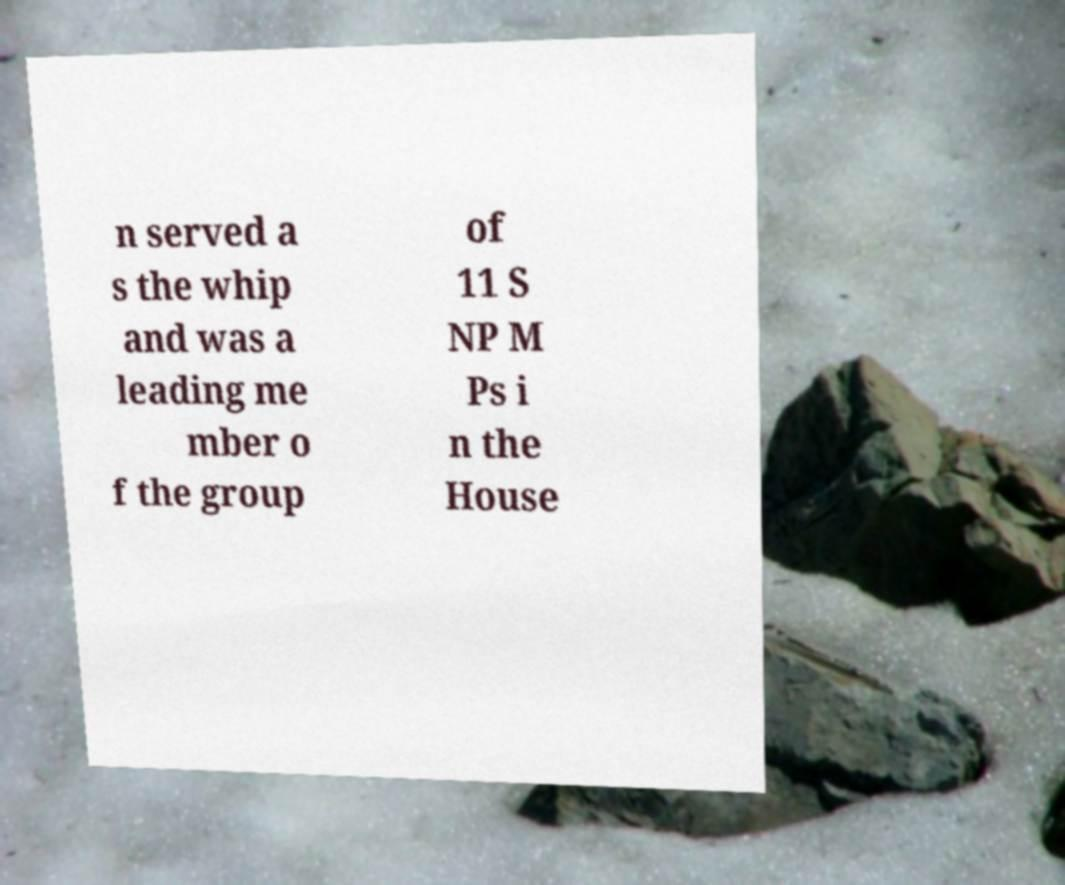Can you read and provide the text displayed in the image?This photo seems to have some interesting text. Can you extract and type it out for me? n served a s the whip and was a leading me mber o f the group of 11 S NP M Ps i n the House 